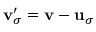Convert formula to latex. <formula><loc_0><loc_0><loc_500><loc_500>{ v } _ { \sigma } ^ { \prime } = { v } - { u } _ { \sigma }</formula> 